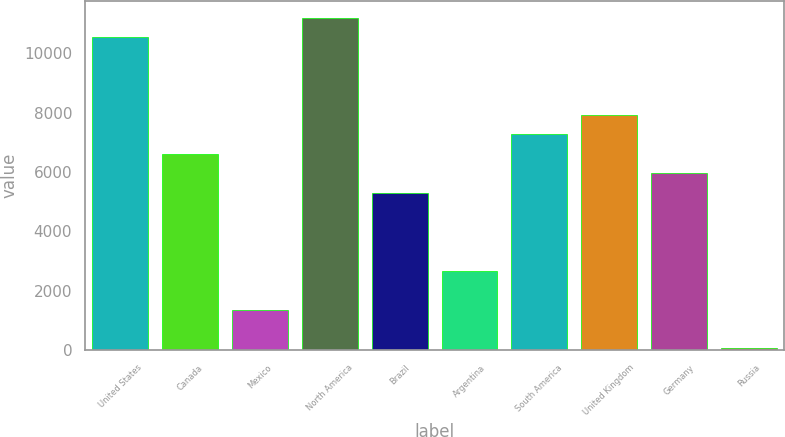Convert chart. <chart><loc_0><loc_0><loc_500><loc_500><bar_chart><fcel>United States<fcel>Canada<fcel>Mexico<fcel>North America<fcel>Brazil<fcel>Argentina<fcel>South America<fcel>United Kingdom<fcel>Germany<fcel>Russia<nl><fcel>10538.8<fcel>6607<fcel>1364.6<fcel>11194.1<fcel>5296.4<fcel>2675.2<fcel>7262.3<fcel>7917.6<fcel>5951.7<fcel>54<nl></chart> 